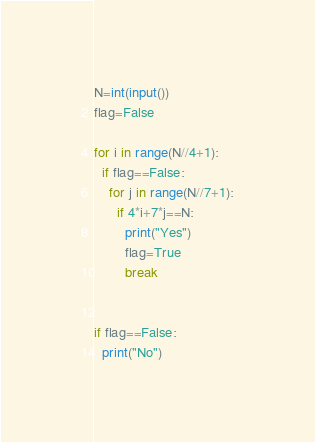Convert code to text. <code><loc_0><loc_0><loc_500><loc_500><_Python_>N=int(input())
flag=False

for i in range(N//4+1):
  if flag==False:
    for j in range(N//7+1):
      if 4*i+7*j==N:
        print("Yes")
        flag=True
        break


if flag==False:
  print("No")</code> 